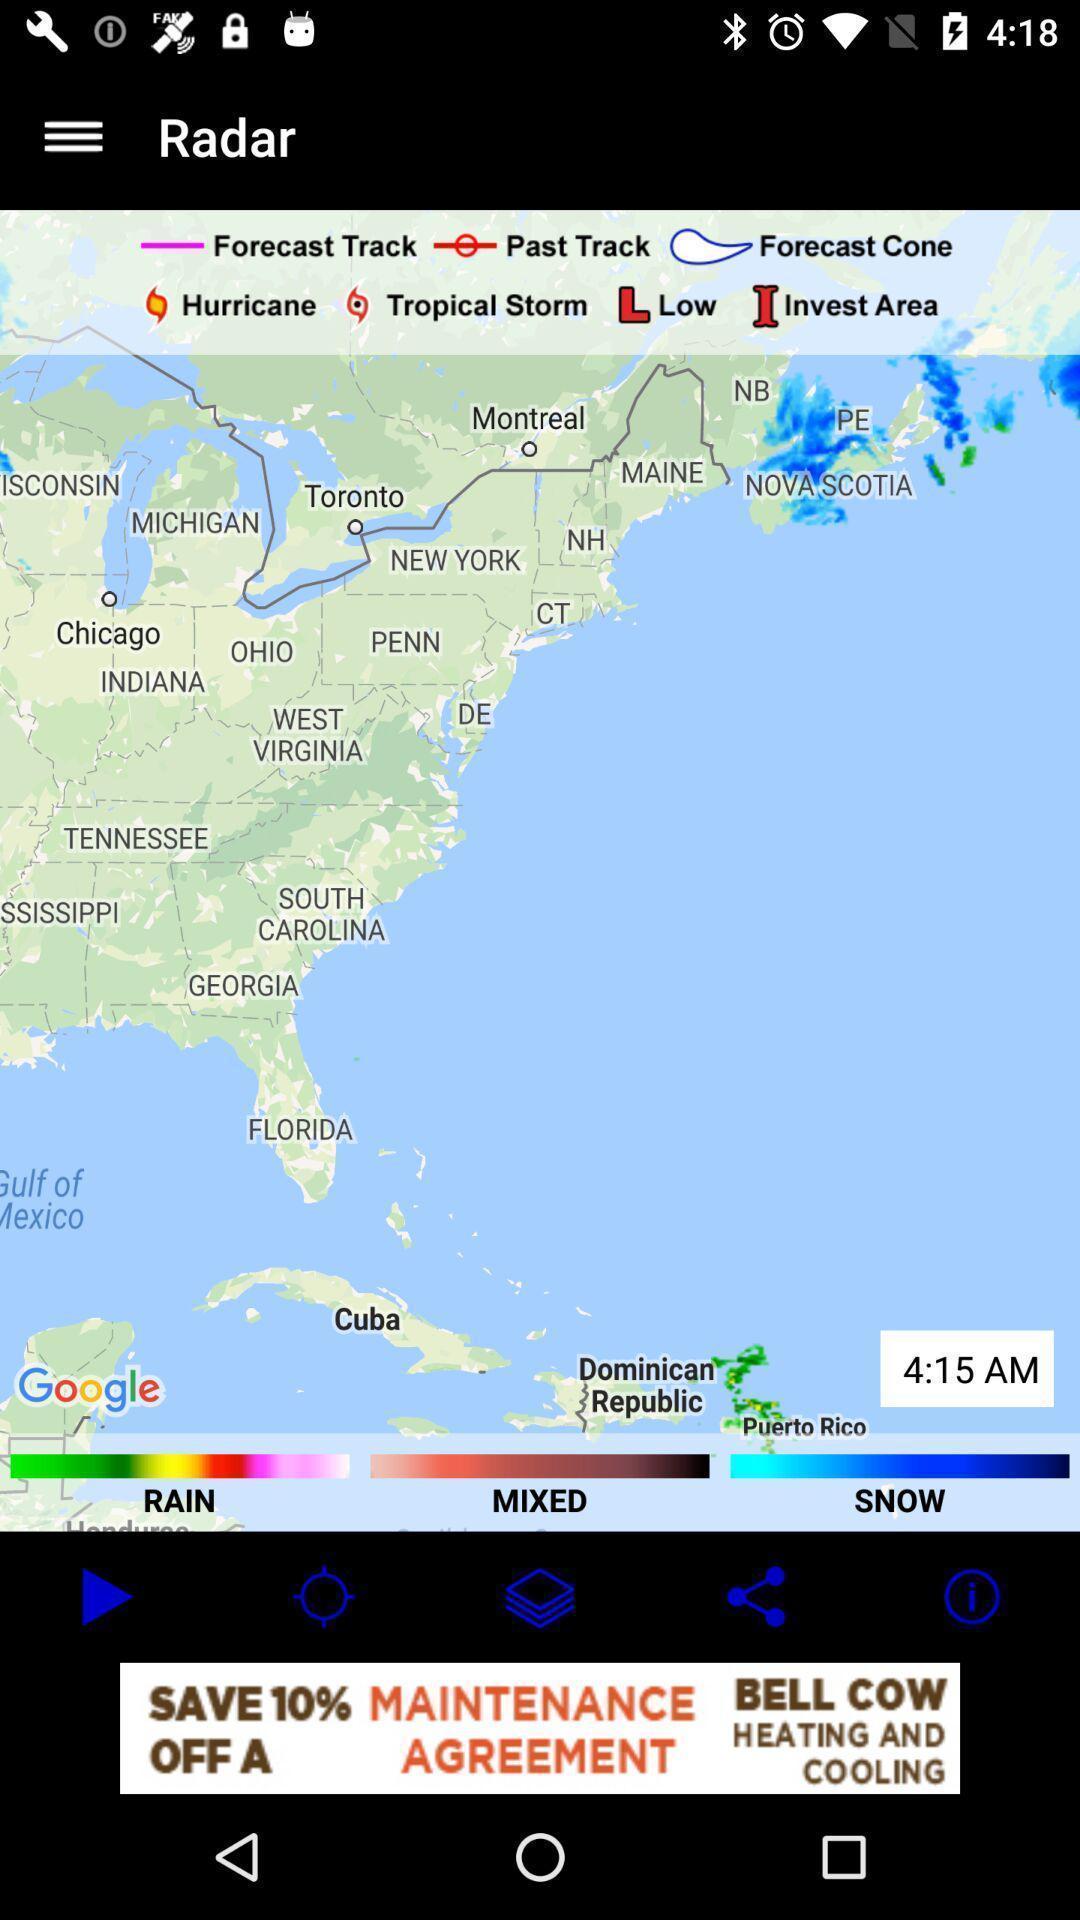Tell me about the visual elements in this screen capture. Page showing map of a place. 